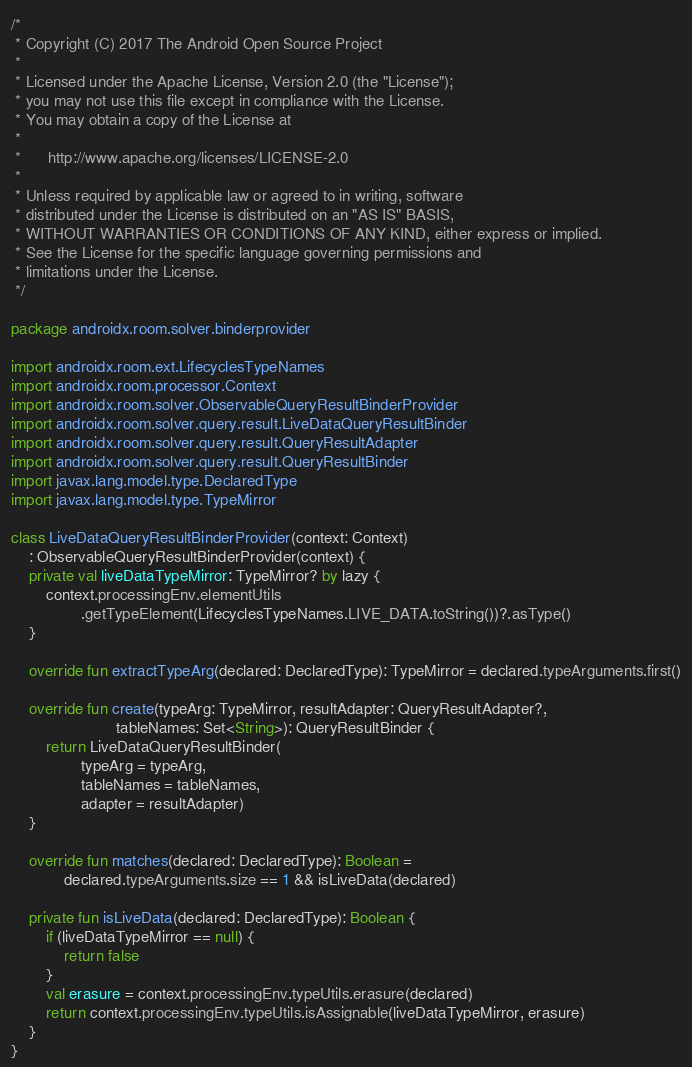Convert code to text. <code><loc_0><loc_0><loc_500><loc_500><_Kotlin_>/*
 * Copyright (C) 2017 The Android Open Source Project
 *
 * Licensed under the Apache License, Version 2.0 (the "License");
 * you may not use this file except in compliance with the License.
 * You may obtain a copy of the License at
 *
 *      http://www.apache.org/licenses/LICENSE-2.0
 *
 * Unless required by applicable law or agreed to in writing, software
 * distributed under the License is distributed on an "AS IS" BASIS,
 * WITHOUT WARRANTIES OR CONDITIONS OF ANY KIND, either express or implied.
 * See the License for the specific language governing permissions and
 * limitations under the License.
 */

package androidx.room.solver.binderprovider

import androidx.room.ext.LifecyclesTypeNames
import androidx.room.processor.Context
import androidx.room.solver.ObservableQueryResultBinderProvider
import androidx.room.solver.query.result.LiveDataQueryResultBinder
import androidx.room.solver.query.result.QueryResultAdapter
import androidx.room.solver.query.result.QueryResultBinder
import javax.lang.model.type.DeclaredType
import javax.lang.model.type.TypeMirror

class LiveDataQueryResultBinderProvider(context: Context)
    : ObservableQueryResultBinderProvider(context) {
    private val liveDataTypeMirror: TypeMirror? by lazy {
        context.processingEnv.elementUtils
                .getTypeElement(LifecyclesTypeNames.LIVE_DATA.toString())?.asType()
    }

    override fun extractTypeArg(declared: DeclaredType): TypeMirror = declared.typeArguments.first()

    override fun create(typeArg: TypeMirror, resultAdapter: QueryResultAdapter?,
                        tableNames: Set<String>): QueryResultBinder {
        return LiveDataQueryResultBinder(
                typeArg = typeArg,
                tableNames = tableNames,
                adapter = resultAdapter)
    }

    override fun matches(declared: DeclaredType): Boolean =
            declared.typeArguments.size == 1 && isLiveData(declared)

    private fun isLiveData(declared: DeclaredType): Boolean {
        if (liveDataTypeMirror == null) {
            return false
        }
        val erasure = context.processingEnv.typeUtils.erasure(declared)
        return context.processingEnv.typeUtils.isAssignable(liveDataTypeMirror, erasure)
    }
}</code> 